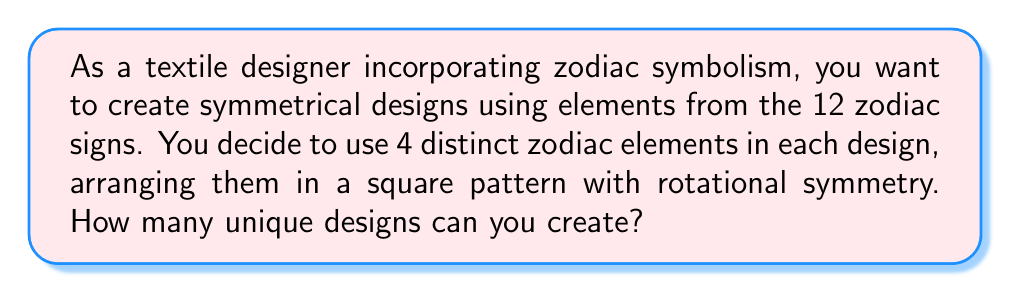Solve this math problem. Let's approach this step-by-step:

1) First, we need to choose 4 distinct zodiac elements out of the 12 available. This can be done in $\binom{12}{4}$ ways.

2) Once we have chosen 4 elements, we need to arrange them in a square pattern with rotational symmetry. This means that rotating the square by 90°, 180°, or 270° should not create a new design.

3) To ensure rotational symmetry, we only need to decide on the placement of the first element. The other three will then be determined to maintain the symmetry.

4) There are 4 positions in the square where we can place the first element.

5) After placing the first element, the arrangements of the other three elements are fixed to maintain rotational symmetry.

6) Therefore, for each selection of 4 zodiac elements, we have 4 possible arrangements.

7) The total number of unique designs is thus:

   $$\binom{12}{4} \times 4$$

8) We can calculate this:
   
   $$\binom{12}{4} = \frac{12!}{4!(12-4)!} = \frac{12!}{4!8!} = 495$$

   $$495 \times 4 = 1980$$

Thus, you can create 1980 unique designs.
Answer: 1980 unique designs 